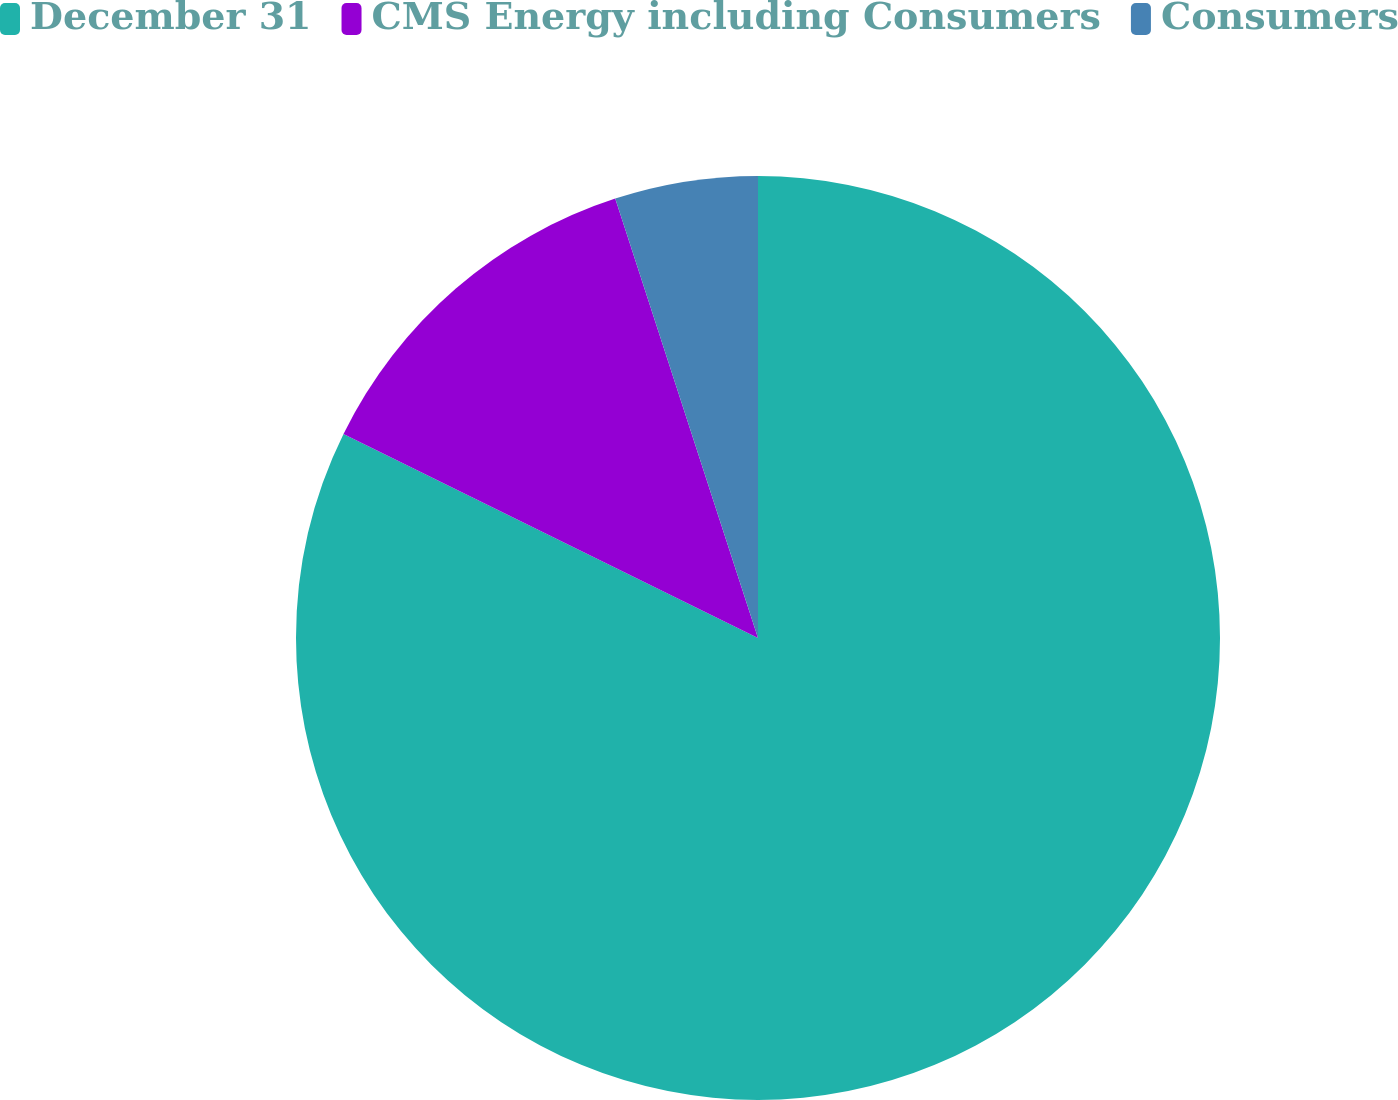Convert chart. <chart><loc_0><loc_0><loc_500><loc_500><pie_chart><fcel>December 31<fcel>CMS Energy including Consumers<fcel>Consumers<nl><fcel>82.28%<fcel>12.72%<fcel>5.0%<nl></chart> 